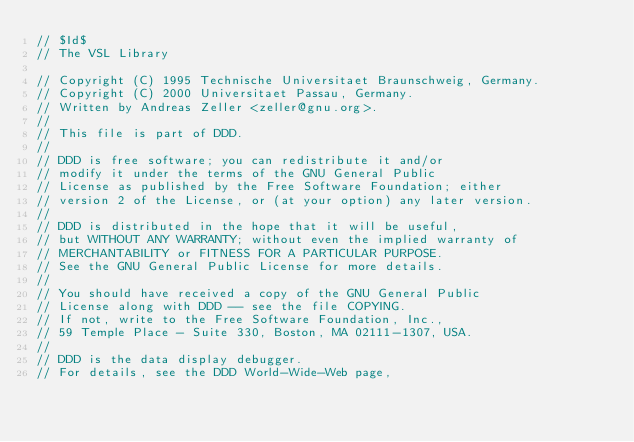Convert code to text. <code><loc_0><loc_0><loc_500><loc_500><_C_>// $Id$ 
// The VSL Library

// Copyright (C) 1995 Technische Universitaet Braunschweig, Germany.
// Copyright (C) 2000 Universitaet Passau, Germany.
// Written by Andreas Zeller <zeller@gnu.org>.
// 
// This file is part of DDD.
// 
// DDD is free software; you can redistribute it and/or
// modify it under the terms of the GNU General Public
// License as published by the Free Software Foundation; either
// version 2 of the License, or (at your option) any later version.
// 
// DDD is distributed in the hope that it will be useful,
// but WITHOUT ANY WARRANTY; without even the implied warranty of
// MERCHANTABILITY or FITNESS FOR A PARTICULAR PURPOSE.
// See the GNU General Public License for more details.
// 
// You should have received a copy of the GNU General Public
// License along with DDD -- see the file COPYING.
// If not, write to the Free Software Foundation, Inc.,
// 59 Temple Place - Suite 330, Boston, MA 02111-1307, USA.
// 
// DDD is the data display debugger.
// For details, see the DDD World-Wide-Web page, </code> 